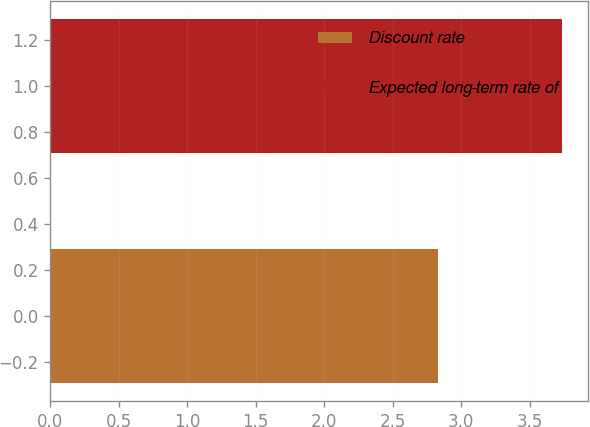Convert chart. <chart><loc_0><loc_0><loc_500><loc_500><bar_chart><fcel>Discount rate<fcel>Expected long-term rate of<nl><fcel>2.83<fcel>3.74<nl></chart> 